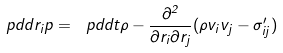<formula> <loc_0><loc_0><loc_500><loc_500>\ p d d { r _ { i } } p = \ p d d { t } \rho - \frac { \partial ^ { 2 } } { \partial r _ { i } \partial r _ { j } } ( \rho v _ { i } v _ { j } - \sigma ^ { \prime } _ { i j } )</formula> 